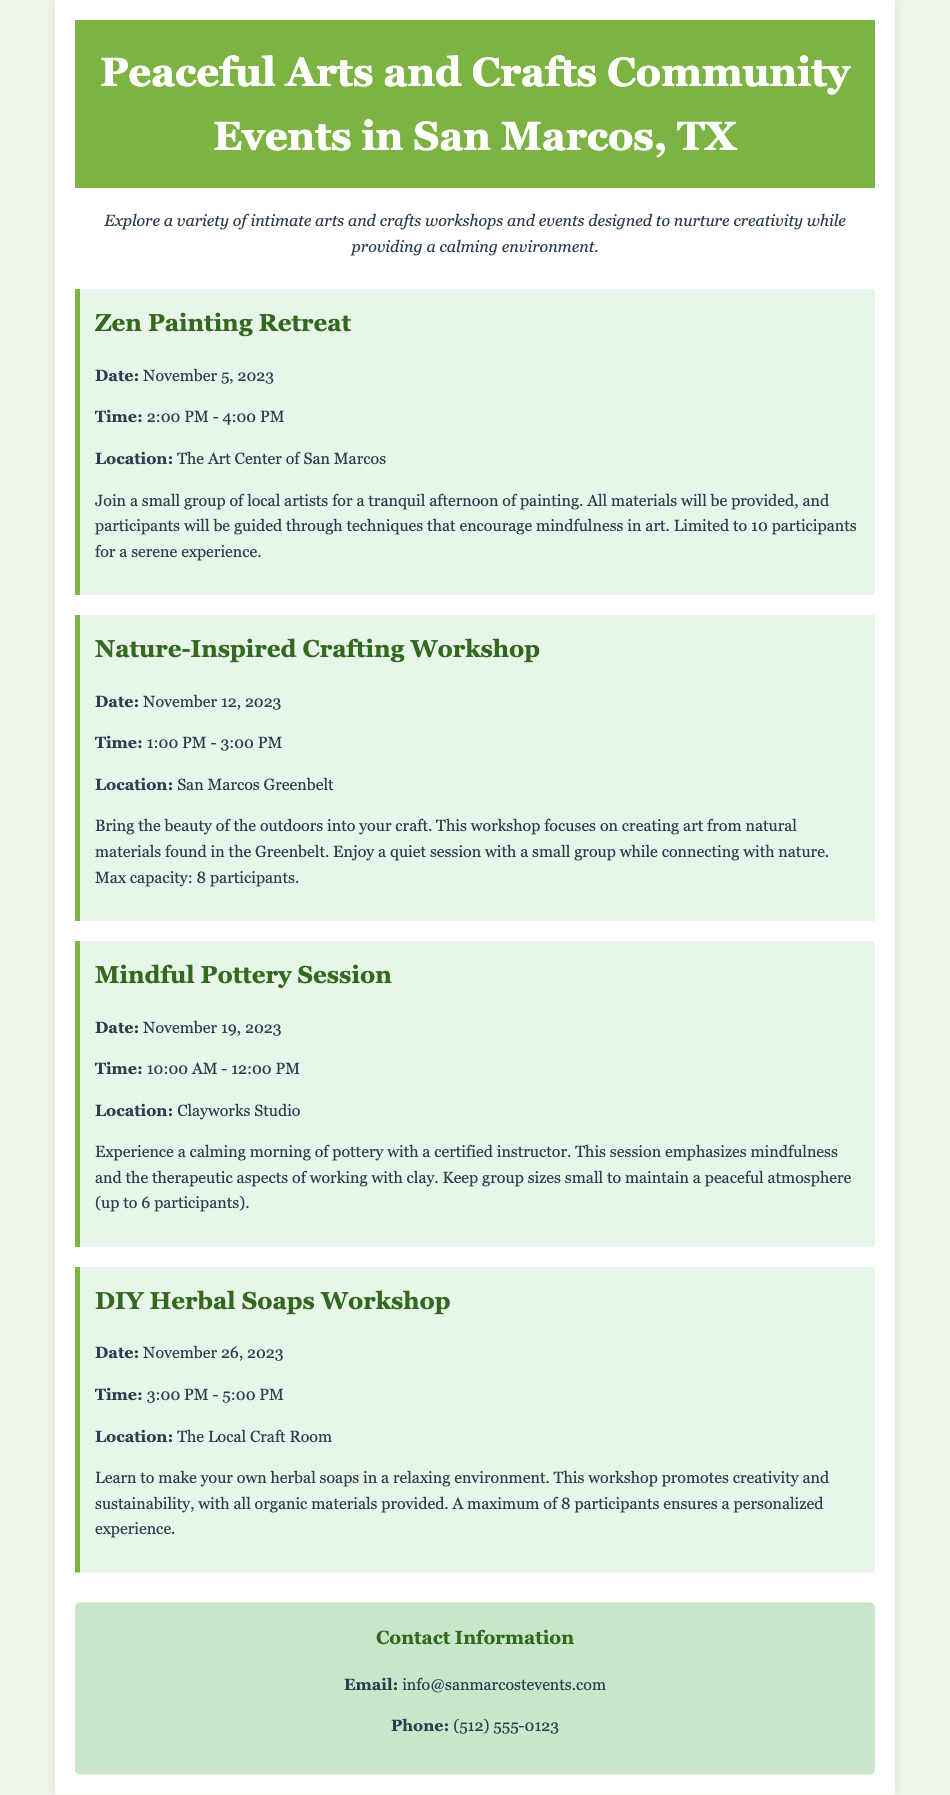What is the title of the catalog? The title of the catalog is found in the header section of the document.
Answer: Peaceful Arts and Crafts Community Events in San Marcos, TX How many participants are allowed in the Zen Painting Retreat? The maximum number of participants for the Zen Painting Retreat is mentioned in the event details.
Answer: 10 participants What date is the Nature-Inspired Crafting Workshop scheduled for? The date can be found right below the title of the event in the document.
Answer: November 12, 2023 What is the location for the DIY Herbal Soaps Workshop? The location is specified in the details of the event.
Answer: The Local Craft Room How long does the Mindful Pottery Session last? The duration can be inferred from the start and end time provided in the event details.
Answer: 2 hours What type of materials are provided for the DIY Herbal Soaps Workshop? The type of materials can be found in the description of the workshop.
Answer: Organic materials What is the main focus of the workshops? The focus is described in the introductory paragraph of the document.
Answer: Intimate gatherings for creativity How many events are listed in the document? The events are counted from the section detailing community activities.
Answer: 4 events 